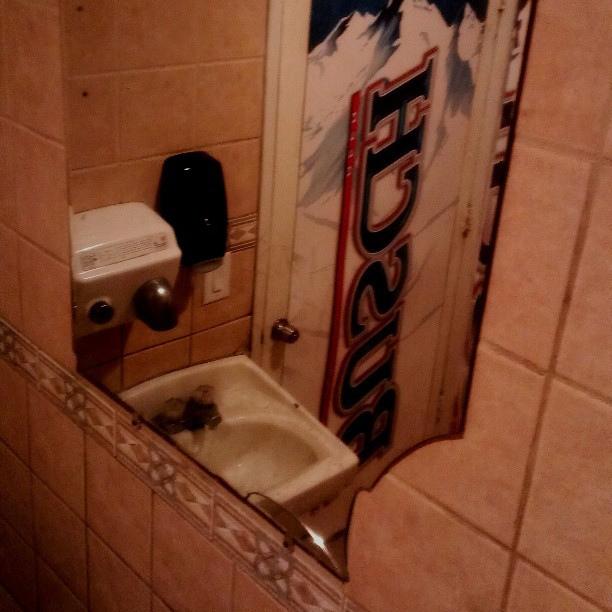What non alcoholic beer is being advertised?
Keep it brief. Busch. Is anything wrong with the mirror?
Write a very short answer. Yes. Does this bathroom appear to be clean?
Quick response, please. No. 